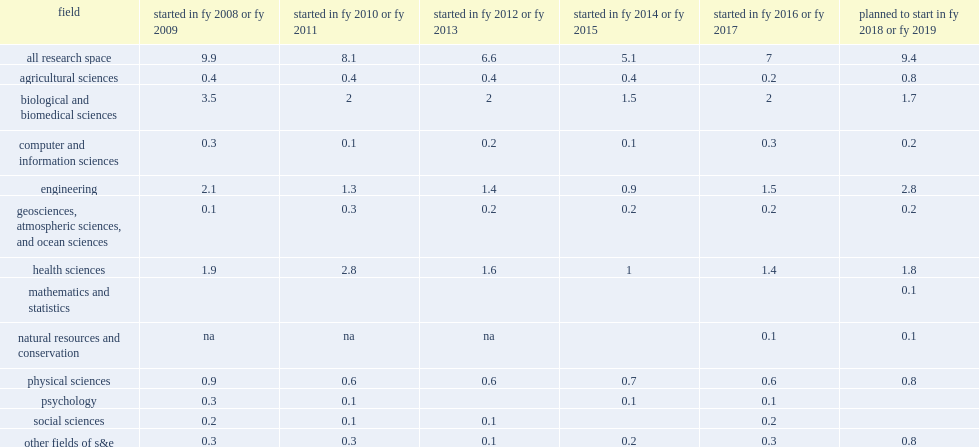How many million nasf of new research space construction did u.s. universities and colleges plan to start in fy 2018 or fy 2019? 9.4. What was the actual amount reported in fy 2017 for that period of nasf? 7.0. 